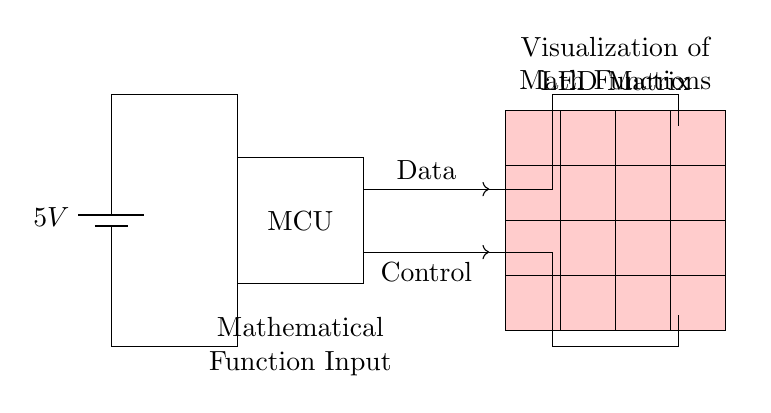What is the supply voltage for the circuit? The supply voltage is indicated by the battery symbol, which shows a voltage of 5V.
Answer: 5V What component is used to control the LED matrix? The microcontroller, depicted by the rectangle labeled "MCU," is responsible for controlling the LED matrix.
Answer: MCU How many rows are in the LED matrix? The LED matrix consists of four rows, as shown in the diagram where there are four horizontal lines of LED nodes.
Answer: 4 What type of signals are sent from the microcontroller to the LED matrix? The microcontroller sends both data and control signals to the LED matrix, as indicated by the arrows labeled "Data" and "Control."
Answer: Data and Control What is the function of the "Mathematical Function Input" label? This label indicates the point in the circuit where mathematical functions are entered, which the microcontroller will process to visualize on the LED matrix.
Answer: Input for functions If the power supply fails, what could happen to the visualization on the LED matrix? If the power supply fails, there will be no voltage available, which means the microcontroller and the LED matrix will not function, resulting in no visualization.
Answer: No visualization How are the LED nodes organized in the LED matrix? The LED nodes are organized in a matrix format with each node representing a pixel in a grid, specifically in a 4 by 4 arrangement.
Answer: 4 by 4 grid 